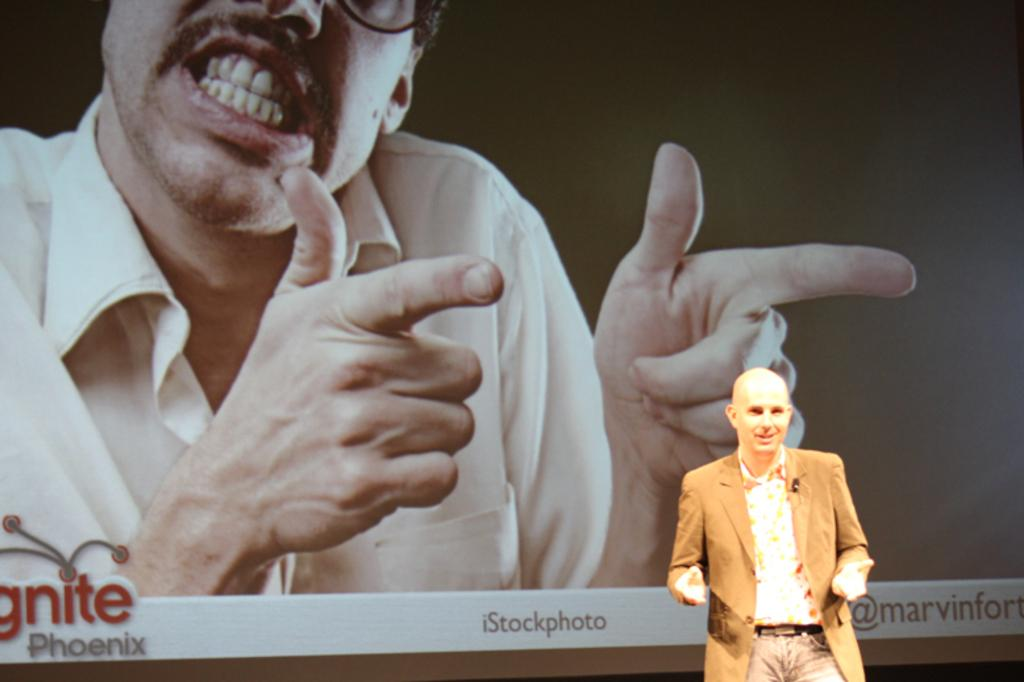Where is the man located in the image? The man is standing in the bottom right corner of the image. What can be seen in the background of the image? There is a screen in the background of the image. What is happening on the screen? A person is visible on the screen. What else can be seen on the screen besides the person? Text is present on the screen. What type of ocean can be seen in the image? There is no ocean present in the image. How does the man twist the plough in the image? There is no plough or twisting action in the image; the man is simply standing in the corner. 